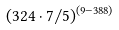Convert formula to latex. <formula><loc_0><loc_0><loc_500><loc_500>( 3 2 4 \cdot 7 / 5 ) ^ { ( 9 - 3 8 8 ) }</formula> 